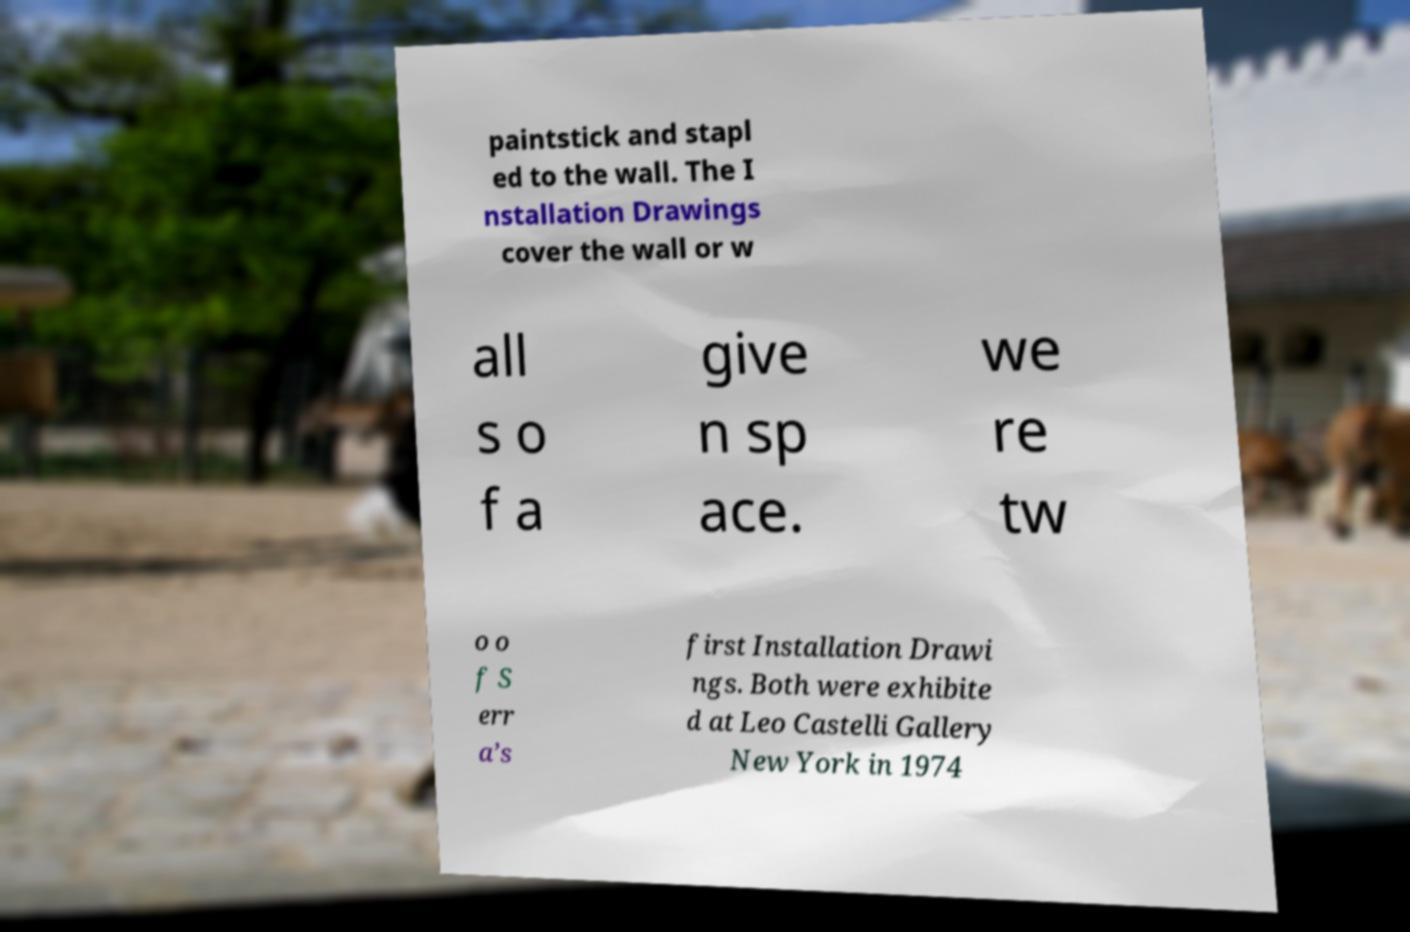For documentation purposes, I need the text within this image transcribed. Could you provide that? paintstick and stapl ed to the wall. The I nstallation Drawings cover the wall or w all s o f a give n sp ace. we re tw o o f S err a’s first Installation Drawi ngs. Both were exhibite d at Leo Castelli Gallery New York in 1974 